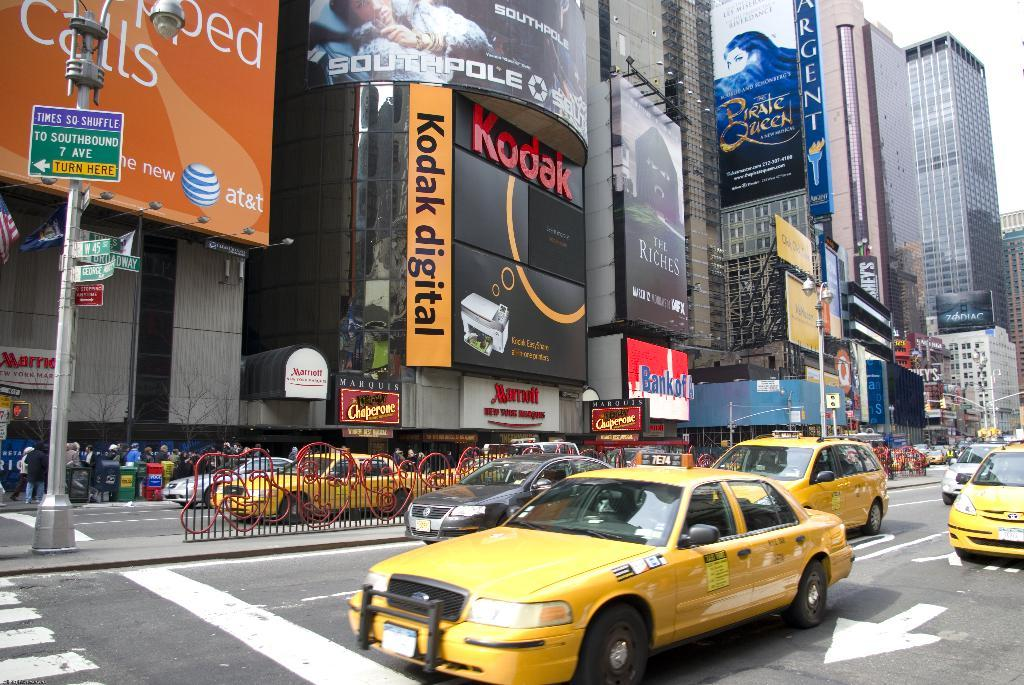<image>
Write a terse but informative summary of the picture. A group of yellow taxis are in a downtown intersection under a sign that says Kodak digital. 